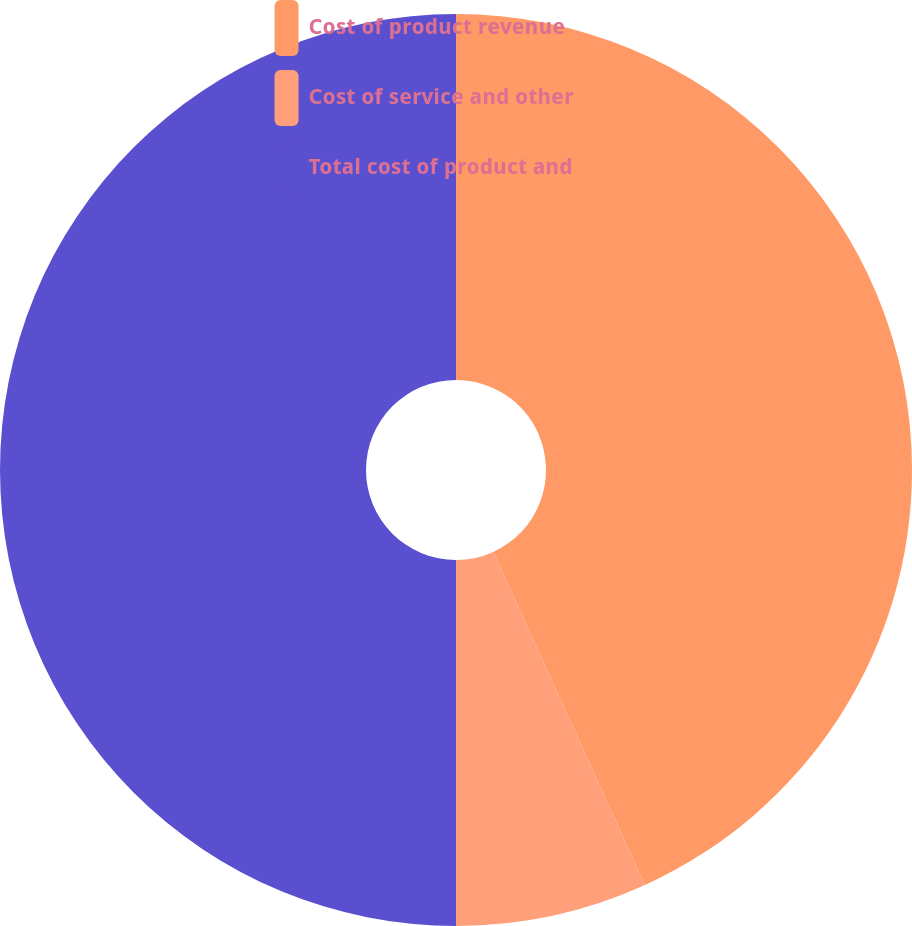Convert chart to OTSL. <chart><loc_0><loc_0><loc_500><loc_500><pie_chart><fcel>Cost of product revenue<fcel>Cost of service and other<fcel>Total cost of product and<nl><fcel>43.2%<fcel>6.8%<fcel>50.0%<nl></chart> 